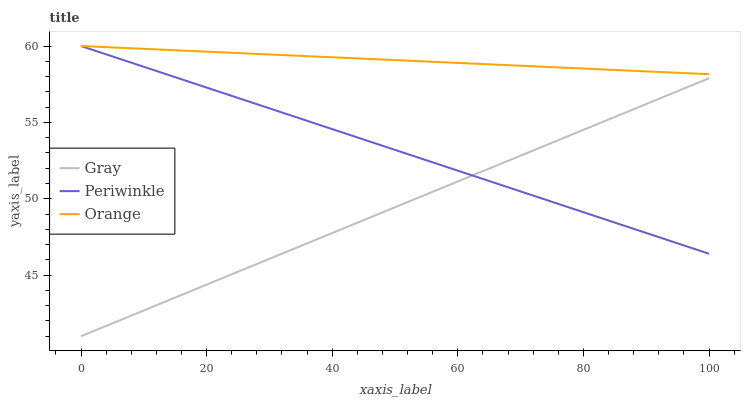Does Gray have the minimum area under the curve?
Answer yes or no. Yes. Does Orange have the maximum area under the curve?
Answer yes or no. Yes. Does Periwinkle have the minimum area under the curve?
Answer yes or no. No. Does Periwinkle have the maximum area under the curve?
Answer yes or no. No. Is Orange the smoothest?
Answer yes or no. Yes. Is Gray the roughest?
Answer yes or no. Yes. Is Periwinkle the smoothest?
Answer yes or no. No. Is Periwinkle the roughest?
Answer yes or no. No. Does Gray have the lowest value?
Answer yes or no. Yes. Does Periwinkle have the lowest value?
Answer yes or no. No. Does Periwinkle have the highest value?
Answer yes or no. Yes. Does Gray have the highest value?
Answer yes or no. No. Is Gray less than Orange?
Answer yes or no. Yes. Is Orange greater than Gray?
Answer yes or no. Yes. Does Periwinkle intersect Orange?
Answer yes or no. Yes. Is Periwinkle less than Orange?
Answer yes or no. No. Is Periwinkle greater than Orange?
Answer yes or no. No. Does Gray intersect Orange?
Answer yes or no. No. 